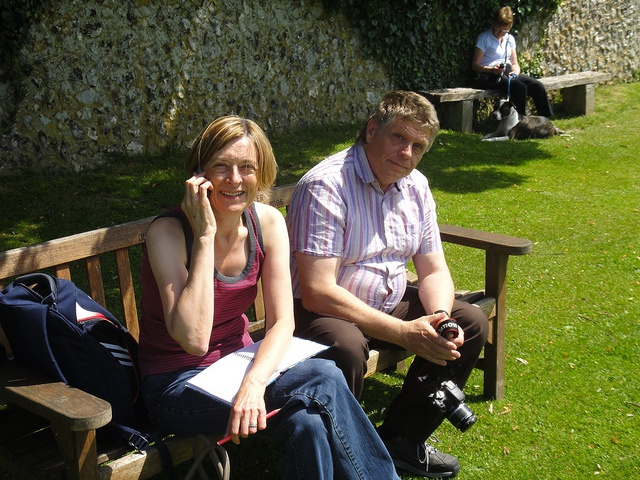Describe the objects in this image and their specific colors. I can see people in black, ivory, maroon, and gray tones, people in black, white, maroon, and gray tones, bench in black, tan, gray, and olive tones, backpack in black, gray, navy, and darkblue tones, and people in black, white, and gray tones in this image. 